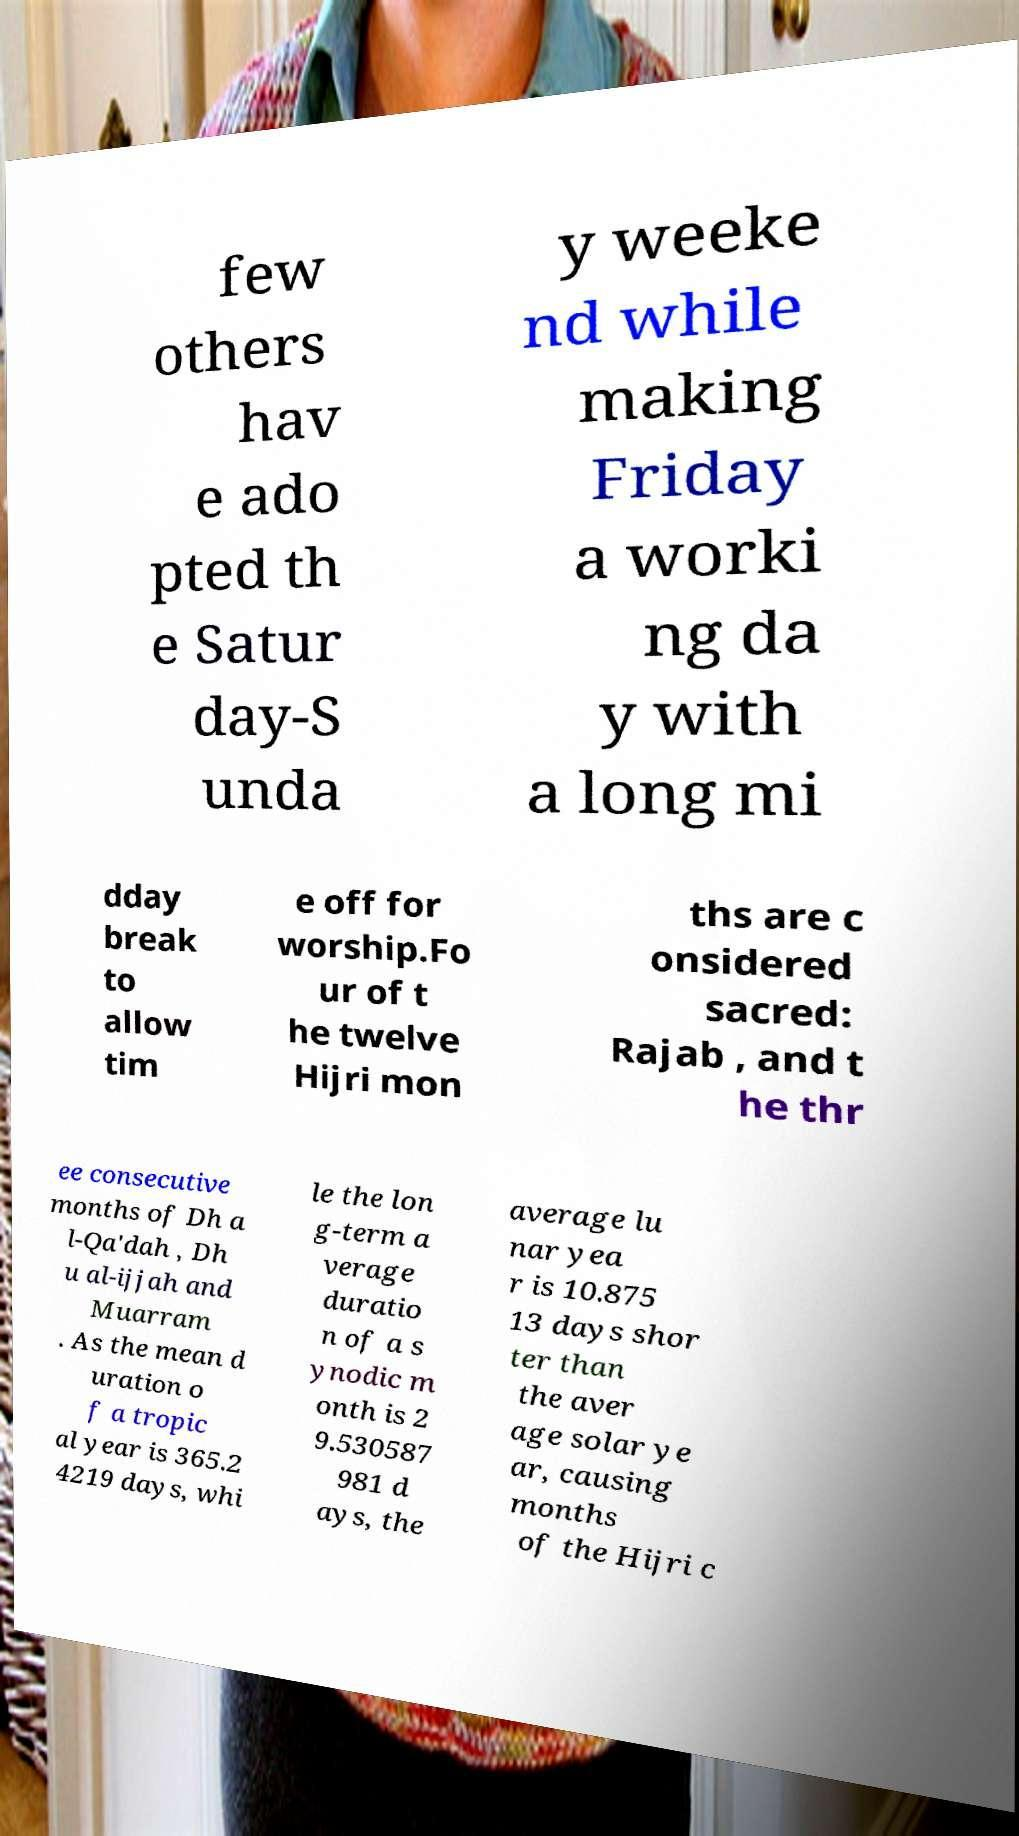Can you read and provide the text displayed in the image?This photo seems to have some interesting text. Can you extract and type it out for me? few others hav e ado pted th e Satur day-S unda y weeke nd while making Friday a worki ng da y with a long mi dday break to allow tim e off for worship.Fo ur of t he twelve Hijri mon ths are c onsidered sacred: Rajab , and t he thr ee consecutive months of Dh a l-Qa'dah , Dh u al-ijjah and Muarram . As the mean d uration o f a tropic al year is 365.2 4219 days, whi le the lon g-term a verage duratio n of a s ynodic m onth is 2 9.530587 981 d ays, the average lu nar yea r is 10.875 13 days shor ter than the aver age solar ye ar, causing months of the Hijri c 